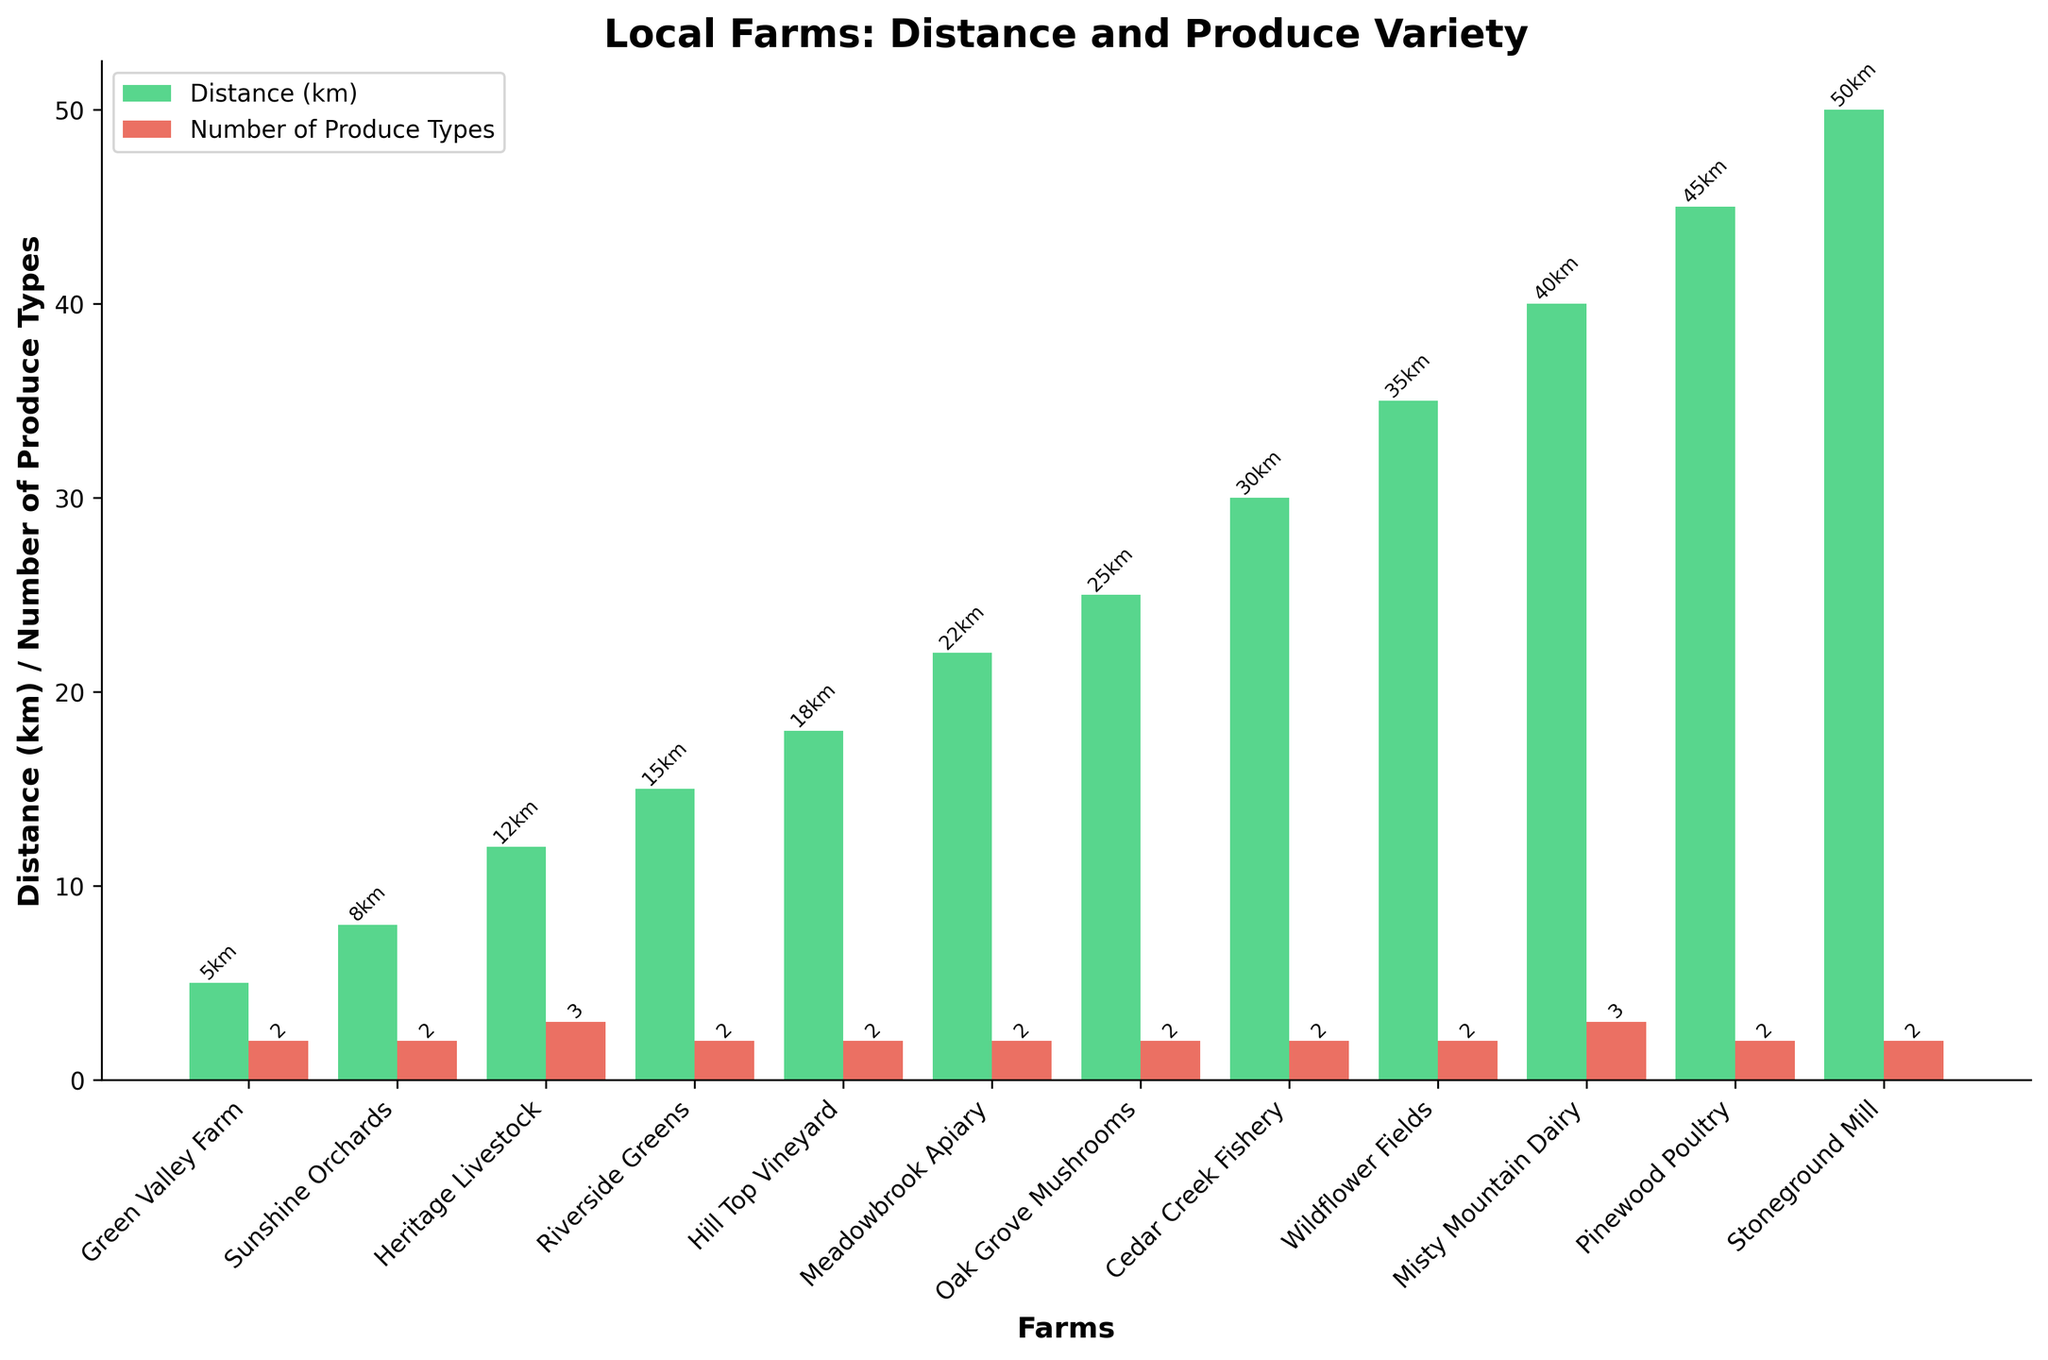Which farm offers the most types of produce? Look at the red bars in the plot, which represent the number of produce types offered by each farm. Find the tallest red bar.
Answer: Heritage Livestock and Misty Mountain Dairy Which farm is located the furthest from the restaurant? Look at the green bars in the plot, which represent the distance of each farm from the restaurant. Find the tallest green bar.
Answer: Stoneground Mill How many farms offer exactly 2 types of produce? Count the number of red bars that reach the height representing 2 types of produce.
Answer: 9 Which farm is closest to the restaurant? Look at the green bars in the plot and identify the shortest one.
Answer: Green Valley Farm Which farm offers both vegetables and herbs? Identify the farm with the matching produce types. Reference the x-axis labels and the number of produce types offered for verification.
Answer: Green Valley Farm What is the average number of produce types offered by farms within 20 km? Identify the farms within 20 km by checking the green bar heights. Sum their produce types (red bars) and divide by the number of farms: (2 + 2 + 3 + 2 + 2) / 5.
Answer: 2.2 Compare the distance and produce variety of Heritage Livestock and Sunshine Orchards. Which farm offers more variety, and which is farther? Compare the height of the green and red bars of both farms. Heritage Livestock has a taller red bar (more variety) and is farther than Sunshine Orchards.
Answer: Heritage Livestock offers more variety and is farther What is the total distance for all farms combined? Sum the distances represented by green bars for all the farms: 5 + 8 + 12 + 15 + 18 + 22 + 25 + 30 + 35 + 40 + 45 + 50.
Answer: 305 km How much farther is Misty Mountain Dairy compared to Wildflower Fields? Look at the heights of the green bars for both farms and subtract the distance of Wildflower Fields from Misty Mountain Dairy: 40 - 35.
Answer: 5 km Which farm offers honey and how far is it from the restaurant? Identify the farm with honey in its produce types and check its corresponding green bar for distance.
Answer: Meadowbrook Apiary, 22 km 